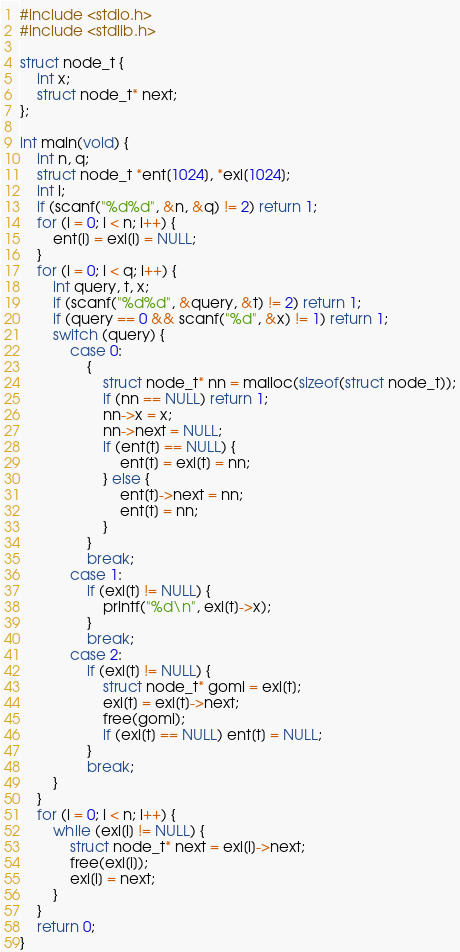<code> <loc_0><loc_0><loc_500><loc_500><_C_>#include <stdio.h>
#include <stdlib.h>

struct node_t {
	int x;
	struct node_t* next;
};

int main(void) {
	int n, q;
	struct node_t *ent[1024], *exi[1024];
	int i;
	if (scanf("%d%d", &n, &q) != 2) return 1;
	for (i = 0; i < n; i++) {
		ent[i] = exi[i] = NULL;
	}
	for (i = 0; i < q; i++) {
		int query, t, x;
		if (scanf("%d%d", &query, &t) != 2) return 1;
		if (query == 0 && scanf("%d", &x) != 1) return 1;
		switch (query) {
			case 0:
				{
					struct node_t* nn = malloc(sizeof(struct node_t));
					if (nn == NULL) return 1;
					nn->x = x;
					nn->next = NULL;
					if (ent[t] == NULL) {
						ent[t] = exi[t] = nn;
					} else {
						ent[t]->next = nn;
						ent[t] = nn;
					}
				}
				break;
			case 1:
				if (exi[t] != NULL) {
					printf("%d\n", exi[t]->x);
				}
				break;
			case 2:
				if (exi[t] != NULL) {
					struct node_t* gomi = exi[t];
					exi[t] = exi[t]->next;
					free(gomi);
					if (exi[t] == NULL) ent[t] = NULL;
				}
				break;
		}
	}
	for (i = 0; i < n; i++) {
		while (exi[i] != NULL) {
			struct node_t* next = exi[i]->next;
			free(exi[i]);
			exi[i] = next;
		}
	}
	return 0;
}

</code> 